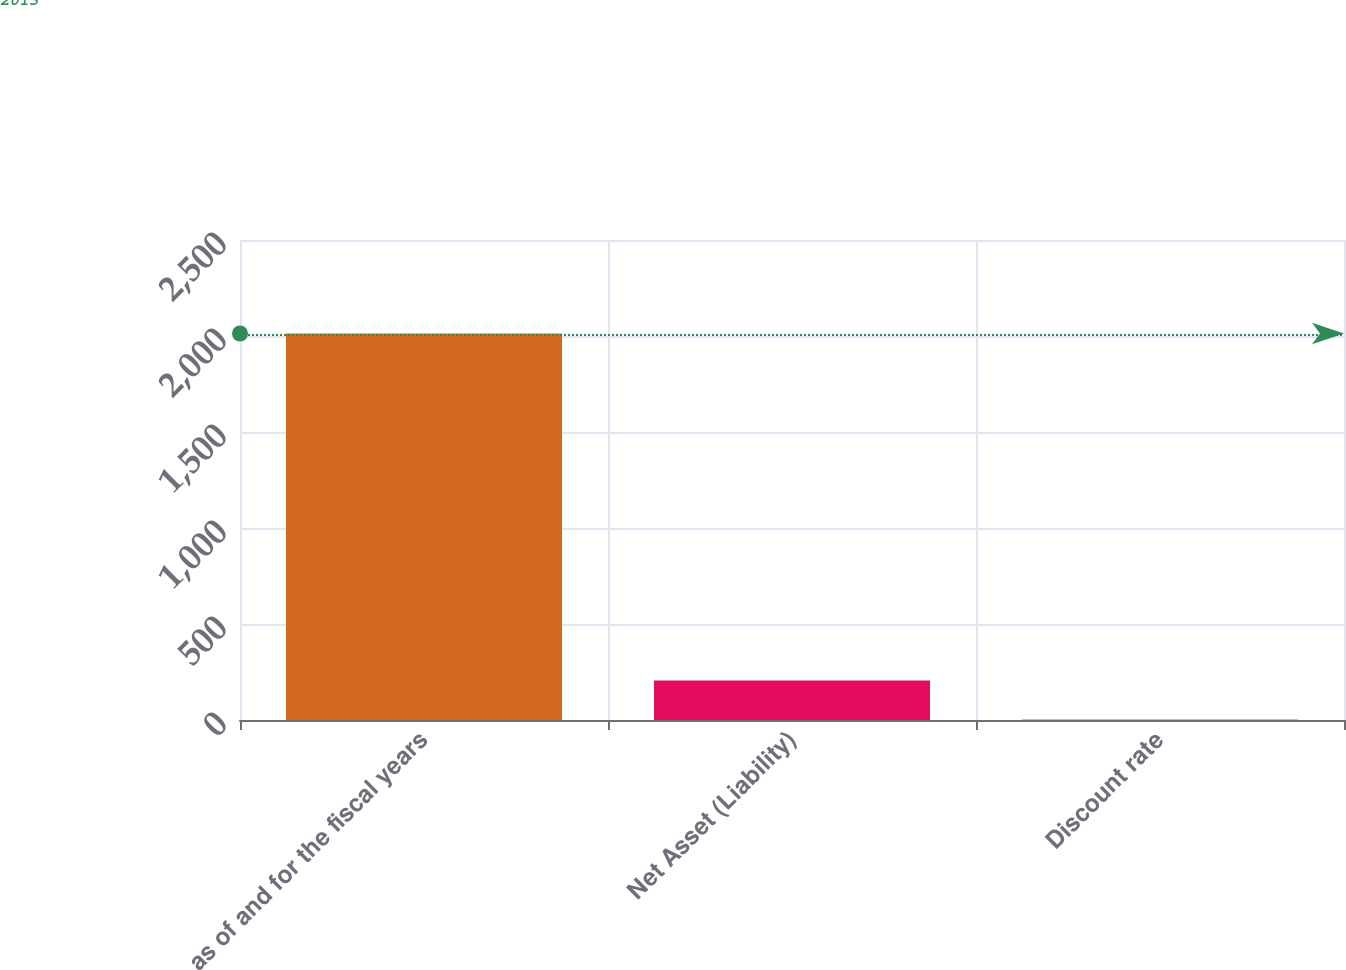Convert chart. <chart><loc_0><loc_0><loc_500><loc_500><bar_chart><fcel>as of and for the fiscal years<fcel>Net Asset (Liability)<fcel>Discount rate<nl><fcel>2013<fcel>205.4<fcel>4.55<nl></chart> 